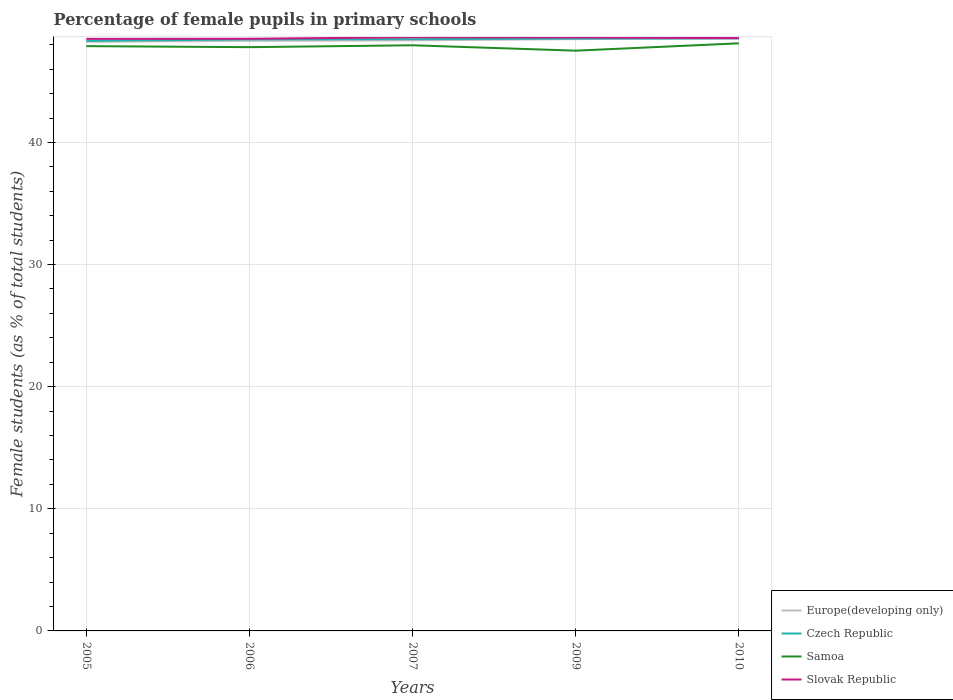How many different coloured lines are there?
Provide a short and direct response. 4. Does the line corresponding to Europe(developing only) intersect with the line corresponding to Czech Republic?
Offer a terse response. No. Is the number of lines equal to the number of legend labels?
Provide a succinct answer. Yes. Across all years, what is the maximum percentage of female pupils in primary schools in Czech Republic?
Your response must be concise. 48.31. What is the total percentage of female pupils in primary schools in Europe(developing only) in the graph?
Keep it short and to the point. -0.15. What is the difference between the highest and the second highest percentage of female pupils in primary schools in Samoa?
Your answer should be very brief. 0.6. What is the difference between the highest and the lowest percentage of female pupils in primary schools in Czech Republic?
Offer a terse response. 3. Is the percentage of female pupils in primary schools in Samoa strictly greater than the percentage of female pupils in primary schools in Slovak Republic over the years?
Offer a terse response. Yes. How many lines are there?
Ensure brevity in your answer.  4. How many years are there in the graph?
Give a very brief answer. 5. Are the values on the major ticks of Y-axis written in scientific E-notation?
Offer a terse response. No. Does the graph contain grids?
Provide a short and direct response. Yes. How are the legend labels stacked?
Keep it short and to the point. Vertical. What is the title of the graph?
Offer a terse response. Percentage of female pupils in primary schools. What is the label or title of the X-axis?
Give a very brief answer. Years. What is the label or title of the Y-axis?
Provide a succinct answer. Female students (as % of total students). What is the Female students (as % of total students) in Europe(developing only) in 2005?
Offer a very short reply. 48.24. What is the Female students (as % of total students) of Czech Republic in 2005?
Ensure brevity in your answer.  48.31. What is the Female students (as % of total students) in Samoa in 2005?
Ensure brevity in your answer.  47.88. What is the Female students (as % of total students) in Slovak Republic in 2005?
Your answer should be compact. 48.48. What is the Female students (as % of total students) of Europe(developing only) in 2006?
Offer a terse response. 48.32. What is the Female students (as % of total students) in Czech Republic in 2006?
Your answer should be very brief. 48.44. What is the Female students (as % of total students) of Samoa in 2006?
Your response must be concise. 47.8. What is the Female students (as % of total students) in Slovak Republic in 2006?
Ensure brevity in your answer.  48.49. What is the Female students (as % of total students) in Europe(developing only) in 2007?
Offer a very short reply. 48.36. What is the Female students (as % of total students) in Czech Republic in 2007?
Your answer should be compact. 48.46. What is the Female students (as % of total students) in Samoa in 2007?
Your response must be concise. 47.95. What is the Female students (as % of total students) of Slovak Republic in 2007?
Your answer should be very brief. 48.61. What is the Female students (as % of total students) in Europe(developing only) in 2009?
Ensure brevity in your answer.  48.46. What is the Female students (as % of total students) in Czech Republic in 2009?
Provide a short and direct response. 48.5. What is the Female students (as % of total students) in Samoa in 2009?
Provide a short and direct response. 47.51. What is the Female students (as % of total students) of Slovak Republic in 2009?
Your answer should be very brief. 48.6. What is the Female students (as % of total students) in Europe(developing only) in 2010?
Make the answer very short. 48.5. What is the Female students (as % of total students) in Czech Republic in 2010?
Provide a short and direct response. 48.53. What is the Female students (as % of total students) of Samoa in 2010?
Ensure brevity in your answer.  48.12. What is the Female students (as % of total students) in Slovak Republic in 2010?
Offer a very short reply. 48.54. Across all years, what is the maximum Female students (as % of total students) of Europe(developing only)?
Ensure brevity in your answer.  48.5. Across all years, what is the maximum Female students (as % of total students) in Czech Republic?
Offer a very short reply. 48.53. Across all years, what is the maximum Female students (as % of total students) of Samoa?
Your answer should be very brief. 48.12. Across all years, what is the maximum Female students (as % of total students) of Slovak Republic?
Give a very brief answer. 48.61. Across all years, what is the minimum Female students (as % of total students) in Europe(developing only)?
Give a very brief answer. 48.24. Across all years, what is the minimum Female students (as % of total students) in Czech Republic?
Provide a short and direct response. 48.31. Across all years, what is the minimum Female students (as % of total students) in Samoa?
Provide a short and direct response. 47.51. Across all years, what is the minimum Female students (as % of total students) of Slovak Republic?
Offer a terse response. 48.48. What is the total Female students (as % of total students) in Europe(developing only) in the graph?
Provide a short and direct response. 241.88. What is the total Female students (as % of total students) in Czech Republic in the graph?
Offer a very short reply. 242.24. What is the total Female students (as % of total students) in Samoa in the graph?
Give a very brief answer. 239.27. What is the total Female students (as % of total students) in Slovak Republic in the graph?
Give a very brief answer. 242.72. What is the difference between the Female students (as % of total students) of Europe(developing only) in 2005 and that in 2006?
Give a very brief answer. -0.07. What is the difference between the Female students (as % of total students) of Czech Republic in 2005 and that in 2006?
Ensure brevity in your answer.  -0.12. What is the difference between the Female students (as % of total students) in Samoa in 2005 and that in 2006?
Provide a succinct answer. 0.08. What is the difference between the Female students (as % of total students) in Slovak Republic in 2005 and that in 2006?
Provide a short and direct response. -0.01. What is the difference between the Female students (as % of total students) of Europe(developing only) in 2005 and that in 2007?
Your answer should be very brief. -0.11. What is the difference between the Female students (as % of total students) of Czech Republic in 2005 and that in 2007?
Keep it short and to the point. -0.14. What is the difference between the Female students (as % of total students) in Samoa in 2005 and that in 2007?
Your answer should be very brief. -0.07. What is the difference between the Female students (as % of total students) of Slovak Republic in 2005 and that in 2007?
Provide a succinct answer. -0.13. What is the difference between the Female students (as % of total students) in Europe(developing only) in 2005 and that in 2009?
Offer a terse response. -0.22. What is the difference between the Female students (as % of total students) in Czech Republic in 2005 and that in 2009?
Provide a succinct answer. -0.19. What is the difference between the Female students (as % of total students) of Samoa in 2005 and that in 2009?
Your answer should be very brief. 0.37. What is the difference between the Female students (as % of total students) of Slovak Republic in 2005 and that in 2009?
Keep it short and to the point. -0.12. What is the difference between the Female students (as % of total students) in Europe(developing only) in 2005 and that in 2010?
Keep it short and to the point. -0.26. What is the difference between the Female students (as % of total students) of Czech Republic in 2005 and that in 2010?
Your answer should be compact. -0.21. What is the difference between the Female students (as % of total students) of Samoa in 2005 and that in 2010?
Offer a terse response. -0.23. What is the difference between the Female students (as % of total students) in Slovak Republic in 2005 and that in 2010?
Offer a very short reply. -0.06. What is the difference between the Female students (as % of total students) in Europe(developing only) in 2006 and that in 2007?
Ensure brevity in your answer.  -0.04. What is the difference between the Female students (as % of total students) of Czech Republic in 2006 and that in 2007?
Give a very brief answer. -0.02. What is the difference between the Female students (as % of total students) in Samoa in 2006 and that in 2007?
Your answer should be very brief. -0.15. What is the difference between the Female students (as % of total students) of Slovak Republic in 2006 and that in 2007?
Provide a succinct answer. -0.12. What is the difference between the Female students (as % of total students) in Europe(developing only) in 2006 and that in 2009?
Offer a terse response. -0.14. What is the difference between the Female students (as % of total students) of Czech Republic in 2006 and that in 2009?
Keep it short and to the point. -0.07. What is the difference between the Female students (as % of total students) in Samoa in 2006 and that in 2009?
Your answer should be compact. 0.29. What is the difference between the Female students (as % of total students) of Slovak Republic in 2006 and that in 2009?
Ensure brevity in your answer.  -0.11. What is the difference between the Female students (as % of total students) in Europe(developing only) in 2006 and that in 2010?
Provide a short and direct response. -0.19. What is the difference between the Female students (as % of total students) in Czech Republic in 2006 and that in 2010?
Ensure brevity in your answer.  -0.09. What is the difference between the Female students (as % of total students) of Samoa in 2006 and that in 2010?
Offer a very short reply. -0.32. What is the difference between the Female students (as % of total students) in Slovak Republic in 2006 and that in 2010?
Provide a succinct answer. -0.05. What is the difference between the Female students (as % of total students) of Europe(developing only) in 2007 and that in 2009?
Provide a short and direct response. -0.1. What is the difference between the Female students (as % of total students) of Czech Republic in 2007 and that in 2009?
Your answer should be compact. -0.05. What is the difference between the Female students (as % of total students) in Samoa in 2007 and that in 2009?
Your answer should be compact. 0.44. What is the difference between the Female students (as % of total students) of Slovak Republic in 2007 and that in 2009?
Your response must be concise. 0.02. What is the difference between the Female students (as % of total students) of Europe(developing only) in 2007 and that in 2010?
Your answer should be compact. -0.15. What is the difference between the Female students (as % of total students) in Czech Republic in 2007 and that in 2010?
Ensure brevity in your answer.  -0.07. What is the difference between the Female students (as % of total students) in Samoa in 2007 and that in 2010?
Make the answer very short. -0.16. What is the difference between the Female students (as % of total students) of Slovak Republic in 2007 and that in 2010?
Make the answer very short. 0.07. What is the difference between the Female students (as % of total students) of Europe(developing only) in 2009 and that in 2010?
Keep it short and to the point. -0.04. What is the difference between the Female students (as % of total students) of Czech Republic in 2009 and that in 2010?
Ensure brevity in your answer.  -0.02. What is the difference between the Female students (as % of total students) of Samoa in 2009 and that in 2010?
Your answer should be compact. -0.6. What is the difference between the Female students (as % of total students) of Slovak Republic in 2009 and that in 2010?
Make the answer very short. 0.06. What is the difference between the Female students (as % of total students) of Europe(developing only) in 2005 and the Female students (as % of total students) of Czech Republic in 2006?
Your answer should be very brief. -0.19. What is the difference between the Female students (as % of total students) of Europe(developing only) in 2005 and the Female students (as % of total students) of Samoa in 2006?
Your response must be concise. 0.44. What is the difference between the Female students (as % of total students) in Europe(developing only) in 2005 and the Female students (as % of total students) in Slovak Republic in 2006?
Keep it short and to the point. -0.24. What is the difference between the Female students (as % of total students) in Czech Republic in 2005 and the Female students (as % of total students) in Samoa in 2006?
Provide a succinct answer. 0.51. What is the difference between the Female students (as % of total students) of Czech Republic in 2005 and the Female students (as % of total students) of Slovak Republic in 2006?
Provide a succinct answer. -0.17. What is the difference between the Female students (as % of total students) of Samoa in 2005 and the Female students (as % of total students) of Slovak Republic in 2006?
Make the answer very short. -0.6. What is the difference between the Female students (as % of total students) in Europe(developing only) in 2005 and the Female students (as % of total students) in Czech Republic in 2007?
Give a very brief answer. -0.21. What is the difference between the Female students (as % of total students) in Europe(developing only) in 2005 and the Female students (as % of total students) in Samoa in 2007?
Give a very brief answer. 0.29. What is the difference between the Female students (as % of total students) in Europe(developing only) in 2005 and the Female students (as % of total students) in Slovak Republic in 2007?
Keep it short and to the point. -0.37. What is the difference between the Female students (as % of total students) in Czech Republic in 2005 and the Female students (as % of total students) in Samoa in 2007?
Keep it short and to the point. 0.36. What is the difference between the Female students (as % of total students) in Czech Republic in 2005 and the Female students (as % of total students) in Slovak Republic in 2007?
Your response must be concise. -0.3. What is the difference between the Female students (as % of total students) in Samoa in 2005 and the Female students (as % of total students) in Slovak Republic in 2007?
Offer a terse response. -0.73. What is the difference between the Female students (as % of total students) in Europe(developing only) in 2005 and the Female students (as % of total students) in Czech Republic in 2009?
Offer a very short reply. -0.26. What is the difference between the Female students (as % of total students) in Europe(developing only) in 2005 and the Female students (as % of total students) in Samoa in 2009?
Provide a succinct answer. 0.73. What is the difference between the Female students (as % of total students) in Europe(developing only) in 2005 and the Female students (as % of total students) in Slovak Republic in 2009?
Your answer should be compact. -0.35. What is the difference between the Female students (as % of total students) of Czech Republic in 2005 and the Female students (as % of total students) of Samoa in 2009?
Your answer should be very brief. 0.8. What is the difference between the Female students (as % of total students) of Czech Republic in 2005 and the Female students (as % of total students) of Slovak Republic in 2009?
Provide a succinct answer. -0.28. What is the difference between the Female students (as % of total students) in Samoa in 2005 and the Female students (as % of total students) in Slovak Republic in 2009?
Make the answer very short. -0.71. What is the difference between the Female students (as % of total students) of Europe(developing only) in 2005 and the Female students (as % of total students) of Czech Republic in 2010?
Ensure brevity in your answer.  -0.28. What is the difference between the Female students (as % of total students) in Europe(developing only) in 2005 and the Female students (as % of total students) in Samoa in 2010?
Offer a very short reply. 0.13. What is the difference between the Female students (as % of total students) of Europe(developing only) in 2005 and the Female students (as % of total students) of Slovak Republic in 2010?
Provide a short and direct response. -0.3. What is the difference between the Female students (as % of total students) of Czech Republic in 2005 and the Female students (as % of total students) of Samoa in 2010?
Your response must be concise. 0.2. What is the difference between the Female students (as % of total students) in Czech Republic in 2005 and the Female students (as % of total students) in Slovak Republic in 2010?
Provide a succinct answer. -0.23. What is the difference between the Female students (as % of total students) in Samoa in 2005 and the Female students (as % of total students) in Slovak Republic in 2010?
Provide a succinct answer. -0.66. What is the difference between the Female students (as % of total students) in Europe(developing only) in 2006 and the Female students (as % of total students) in Czech Republic in 2007?
Offer a terse response. -0.14. What is the difference between the Female students (as % of total students) of Europe(developing only) in 2006 and the Female students (as % of total students) of Samoa in 2007?
Offer a very short reply. 0.36. What is the difference between the Female students (as % of total students) in Europe(developing only) in 2006 and the Female students (as % of total students) in Slovak Republic in 2007?
Provide a succinct answer. -0.3. What is the difference between the Female students (as % of total students) of Czech Republic in 2006 and the Female students (as % of total students) of Samoa in 2007?
Your response must be concise. 0.48. What is the difference between the Female students (as % of total students) in Czech Republic in 2006 and the Female students (as % of total students) in Slovak Republic in 2007?
Provide a succinct answer. -0.17. What is the difference between the Female students (as % of total students) in Samoa in 2006 and the Female students (as % of total students) in Slovak Republic in 2007?
Your response must be concise. -0.81. What is the difference between the Female students (as % of total students) in Europe(developing only) in 2006 and the Female students (as % of total students) in Czech Republic in 2009?
Give a very brief answer. -0.19. What is the difference between the Female students (as % of total students) in Europe(developing only) in 2006 and the Female students (as % of total students) in Samoa in 2009?
Provide a short and direct response. 0.8. What is the difference between the Female students (as % of total students) in Europe(developing only) in 2006 and the Female students (as % of total students) in Slovak Republic in 2009?
Provide a succinct answer. -0.28. What is the difference between the Female students (as % of total students) of Czech Republic in 2006 and the Female students (as % of total students) of Samoa in 2009?
Offer a very short reply. 0.92. What is the difference between the Female students (as % of total students) of Czech Republic in 2006 and the Female students (as % of total students) of Slovak Republic in 2009?
Your answer should be compact. -0.16. What is the difference between the Female students (as % of total students) in Samoa in 2006 and the Female students (as % of total students) in Slovak Republic in 2009?
Your answer should be very brief. -0.8. What is the difference between the Female students (as % of total students) of Europe(developing only) in 2006 and the Female students (as % of total students) of Czech Republic in 2010?
Give a very brief answer. -0.21. What is the difference between the Female students (as % of total students) of Europe(developing only) in 2006 and the Female students (as % of total students) of Samoa in 2010?
Your answer should be very brief. 0.2. What is the difference between the Female students (as % of total students) of Europe(developing only) in 2006 and the Female students (as % of total students) of Slovak Republic in 2010?
Provide a short and direct response. -0.23. What is the difference between the Female students (as % of total students) in Czech Republic in 2006 and the Female students (as % of total students) in Samoa in 2010?
Keep it short and to the point. 0.32. What is the difference between the Female students (as % of total students) in Czech Republic in 2006 and the Female students (as % of total students) in Slovak Republic in 2010?
Ensure brevity in your answer.  -0.1. What is the difference between the Female students (as % of total students) in Samoa in 2006 and the Female students (as % of total students) in Slovak Republic in 2010?
Provide a short and direct response. -0.74. What is the difference between the Female students (as % of total students) of Europe(developing only) in 2007 and the Female students (as % of total students) of Czech Republic in 2009?
Keep it short and to the point. -0.15. What is the difference between the Female students (as % of total students) in Europe(developing only) in 2007 and the Female students (as % of total students) in Samoa in 2009?
Give a very brief answer. 0.84. What is the difference between the Female students (as % of total students) of Europe(developing only) in 2007 and the Female students (as % of total students) of Slovak Republic in 2009?
Ensure brevity in your answer.  -0.24. What is the difference between the Female students (as % of total students) of Czech Republic in 2007 and the Female students (as % of total students) of Samoa in 2009?
Ensure brevity in your answer.  0.94. What is the difference between the Female students (as % of total students) of Czech Republic in 2007 and the Female students (as % of total students) of Slovak Republic in 2009?
Provide a short and direct response. -0.14. What is the difference between the Female students (as % of total students) in Samoa in 2007 and the Female students (as % of total students) in Slovak Republic in 2009?
Give a very brief answer. -0.64. What is the difference between the Female students (as % of total students) in Europe(developing only) in 2007 and the Female students (as % of total students) in Czech Republic in 2010?
Give a very brief answer. -0.17. What is the difference between the Female students (as % of total students) in Europe(developing only) in 2007 and the Female students (as % of total students) in Samoa in 2010?
Provide a succinct answer. 0.24. What is the difference between the Female students (as % of total students) of Europe(developing only) in 2007 and the Female students (as % of total students) of Slovak Republic in 2010?
Provide a succinct answer. -0.18. What is the difference between the Female students (as % of total students) in Czech Republic in 2007 and the Female students (as % of total students) in Samoa in 2010?
Give a very brief answer. 0.34. What is the difference between the Female students (as % of total students) in Czech Republic in 2007 and the Female students (as % of total students) in Slovak Republic in 2010?
Ensure brevity in your answer.  -0.09. What is the difference between the Female students (as % of total students) in Samoa in 2007 and the Female students (as % of total students) in Slovak Republic in 2010?
Offer a very short reply. -0.59. What is the difference between the Female students (as % of total students) in Europe(developing only) in 2009 and the Female students (as % of total students) in Czech Republic in 2010?
Make the answer very short. -0.07. What is the difference between the Female students (as % of total students) in Europe(developing only) in 2009 and the Female students (as % of total students) in Samoa in 2010?
Ensure brevity in your answer.  0.34. What is the difference between the Female students (as % of total students) in Europe(developing only) in 2009 and the Female students (as % of total students) in Slovak Republic in 2010?
Make the answer very short. -0.08. What is the difference between the Female students (as % of total students) in Czech Republic in 2009 and the Female students (as % of total students) in Samoa in 2010?
Ensure brevity in your answer.  0.39. What is the difference between the Female students (as % of total students) of Czech Republic in 2009 and the Female students (as % of total students) of Slovak Republic in 2010?
Give a very brief answer. -0.04. What is the difference between the Female students (as % of total students) in Samoa in 2009 and the Female students (as % of total students) in Slovak Republic in 2010?
Give a very brief answer. -1.03. What is the average Female students (as % of total students) in Europe(developing only) per year?
Your response must be concise. 48.38. What is the average Female students (as % of total students) of Czech Republic per year?
Give a very brief answer. 48.45. What is the average Female students (as % of total students) in Samoa per year?
Your answer should be compact. 47.85. What is the average Female students (as % of total students) of Slovak Republic per year?
Keep it short and to the point. 48.54. In the year 2005, what is the difference between the Female students (as % of total students) of Europe(developing only) and Female students (as % of total students) of Czech Republic?
Offer a very short reply. -0.07. In the year 2005, what is the difference between the Female students (as % of total students) of Europe(developing only) and Female students (as % of total students) of Samoa?
Provide a succinct answer. 0.36. In the year 2005, what is the difference between the Female students (as % of total students) in Europe(developing only) and Female students (as % of total students) in Slovak Republic?
Your answer should be very brief. -0.24. In the year 2005, what is the difference between the Female students (as % of total students) in Czech Republic and Female students (as % of total students) in Samoa?
Keep it short and to the point. 0.43. In the year 2005, what is the difference between the Female students (as % of total students) of Czech Republic and Female students (as % of total students) of Slovak Republic?
Provide a short and direct response. -0.17. In the year 2005, what is the difference between the Female students (as % of total students) in Samoa and Female students (as % of total students) in Slovak Republic?
Keep it short and to the point. -0.6. In the year 2006, what is the difference between the Female students (as % of total students) of Europe(developing only) and Female students (as % of total students) of Czech Republic?
Give a very brief answer. -0.12. In the year 2006, what is the difference between the Female students (as % of total students) in Europe(developing only) and Female students (as % of total students) in Samoa?
Keep it short and to the point. 0.52. In the year 2006, what is the difference between the Female students (as % of total students) of Europe(developing only) and Female students (as % of total students) of Slovak Republic?
Provide a short and direct response. -0.17. In the year 2006, what is the difference between the Female students (as % of total students) of Czech Republic and Female students (as % of total students) of Samoa?
Keep it short and to the point. 0.64. In the year 2006, what is the difference between the Female students (as % of total students) of Czech Republic and Female students (as % of total students) of Slovak Republic?
Your response must be concise. -0.05. In the year 2006, what is the difference between the Female students (as % of total students) of Samoa and Female students (as % of total students) of Slovak Republic?
Offer a very short reply. -0.69. In the year 2007, what is the difference between the Female students (as % of total students) of Europe(developing only) and Female students (as % of total students) of Czech Republic?
Your answer should be very brief. -0.1. In the year 2007, what is the difference between the Female students (as % of total students) in Europe(developing only) and Female students (as % of total students) in Samoa?
Provide a short and direct response. 0.4. In the year 2007, what is the difference between the Female students (as % of total students) of Europe(developing only) and Female students (as % of total students) of Slovak Republic?
Offer a terse response. -0.26. In the year 2007, what is the difference between the Female students (as % of total students) of Czech Republic and Female students (as % of total students) of Samoa?
Offer a very short reply. 0.5. In the year 2007, what is the difference between the Female students (as % of total students) of Czech Republic and Female students (as % of total students) of Slovak Republic?
Your answer should be compact. -0.16. In the year 2007, what is the difference between the Female students (as % of total students) in Samoa and Female students (as % of total students) in Slovak Republic?
Keep it short and to the point. -0.66. In the year 2009, what is the difference between the Female students (as % of total students) in Europe(developing only) and Female students (as % of total students) in Czech Republic?
Give a very brief answer. -0.04. In the year 2009, what is the difference between the Female students (as % of total students) of Europe(developing only) and Female students (as % of total students) of Samoa?
Your response must be concise. 0.95. In the year 2009, what is the difference between the Female students (as % of total students) of Europe(developing only) and Female students (as % of total students) of Slovak Republic?
Keep it short and to the point. -0.14. In the year 2009, what is the difference between the Female students (as % of total students) of Czech Republic and Female students (as % of total students) of Samoa?
Provide a short and direct response. 0.99. In the year 2009, what is the difference between the Female students (as % of total students) of Czech Republic and Female students (as % of total students) of Slovak Republic?
Provide a short and direct response. -0.09. In the year 2009, what is the difference between the Female students (as % of total students) in Samoa and Female students (as % of total students) in Slovak Republic?
Offer a very short reply. -1.08. In the year 2010, what is the difference between the Female students (as % of total students) in Europe(developing only) and Female students (as % of total students) in Czech Republic?
Your response must be concise. -0.02. In the year 2010, what is the difference between the Female students (as % of total students) in Europe(developing only) and Female students (as % of total students) in Samoa?
Provide a short and direct response. 0.39. In the year 2010, what is the difference between the Female students (as % of total students) in Europe(developing only) and Female students (as % of total students) in Slovak Republic?
Make the answer very short. -0.04. In the year 2010, what is the difference between the Female students (as % of total students) of Czech Republic and Female students (as % of total students) of Samoa?
Your response must be concise. 0.41. In the year 2010, what is the difference between the Female students (as % of total students) of Czech Republic and Female students (as % of total students) of Slovak Republic?
Offer a terse response. -0.02. In the year 2010, what is the difference between the Female students (as % of total students) of Samoa and Female students (as % of total students) of Slovak Republic?
Your answer should be compact. -0.43. What is the ratio of the Female students (as % of total students) in Samoa in 2005 to that in 2006?
Give a very brief answer. 1. What is the ratio of the Female students (as % of total students) in Slovak Republic in 2005 to that in 2006?
Keep it short and to the point. 1. What is the ratio of the Female students (as % of total students) in Europe(developing only) in 2005 to that in 2007?
Your answer should be very brief. 1. What is the ratio of the Female students (as % of total students) of Samoa in 2005 to that in 2009?
Offer a terse response. 1.01. What is the ratio of the Female students (as % of total students) in Europe(developing only) in 2005 to that in 2010?
Offer a very short reply. 0.99. What is the ratio of the Female students (as % of total students) of Slovak Republic in 2005 to that in 2010?
Provide a succinct answer. 1. What is the ratio of the Female students (as % of total students) of Europe(developing only) in 2006 to that in 2007?
Your response must be concise. 1. What is the ratio of the Female students (as % of total students) of Slovak Republic in 2006 to that in 2007?
Your answer should be compact. 1. What is the ratio of the Female students (as % of total students) in Czech Republic in 2006 to that in 2009?
Offer a terse response. 1. What is the ratio of the Female students (as % of total students) of Samoa in 2006 to that in 2009?
Your answer should be very brief. 1.01. What is the ratio of the Female students (as % of total students) in Slovak Republic in 2006 to that in 2009?
Offer a very short reply. 1. What is the ratio of the Female students (as % of total students) of Czech Republic in 2006 to that in 2010?
Offer a very short reply. 1. What is the ratio of the Female students (as % of total students) in Europe(developing only) in 2007 to that in 2009?
Ensure brevity in your answer.  1. What is the ratio of the Female students (as % of total students) of Czech Republic in 2007 to that in 2009?
Offer a very short reply. 1. What is the ratio of the Female students (as % of total students) in Samoa in 2007 to that in 2009?
Your response must be concise. 1.01. What is the ratio of the Female students (as % of total students) in Europe(developing only) in 2007 to that in 2010?
Keep it short and to the point. 1. What is the ratio of the Female students (as % of total students) in Slovak Republic in 2007 to that in 2010?
Your answer should be very brief. 1. What is the ratio of the Female students (as % of total students) of Czech Republic in 2009 to that in 2010?
Offer a terse response. 1. What is the ratio of the Female students (as % of total students) of Samoa in 2009 to that in 2010?
Make the answer very short. 0.99. What is the ratio of the Female students (as % of total students) of Slovak Republic in 2009 to that in 2010?
Provide a succinct answer. 1. What is the difference between the highest and the second highest Female students (as % of total students) of Europe(developing only)?
Keep it short and to the point. 0.04. What is the difference between the highest and the second highest Female students (as % of total students) of Czech Republic?
Provide a succinct answer. 0.02. What is the difference between the highest and the second highest Female students (as % of total students) in Samoa?
Give a very brief answer. 0.16. What is the difference between the highest and the second highest Female students (as % of total students) in Slovak Republic?
Make the answer very short. 0.02. What is the difference between the highest and the lowest Female students (as % of total students) of Europe(developing only)?
Your response must be concise. 0.26. What is the difference between the highest and the lowest Female students (as % of total students) in Czech Republic?
Keep it short and to the point. 0.21. What is the difference between the highest and the lowest Female students (as % of total students) in Samoa?
Your response must be concise. 0.6. What is the difference between the highest and the lowest Female students (as % of total students) of Slovak Republic?
Offer a terse response. 0.13. 